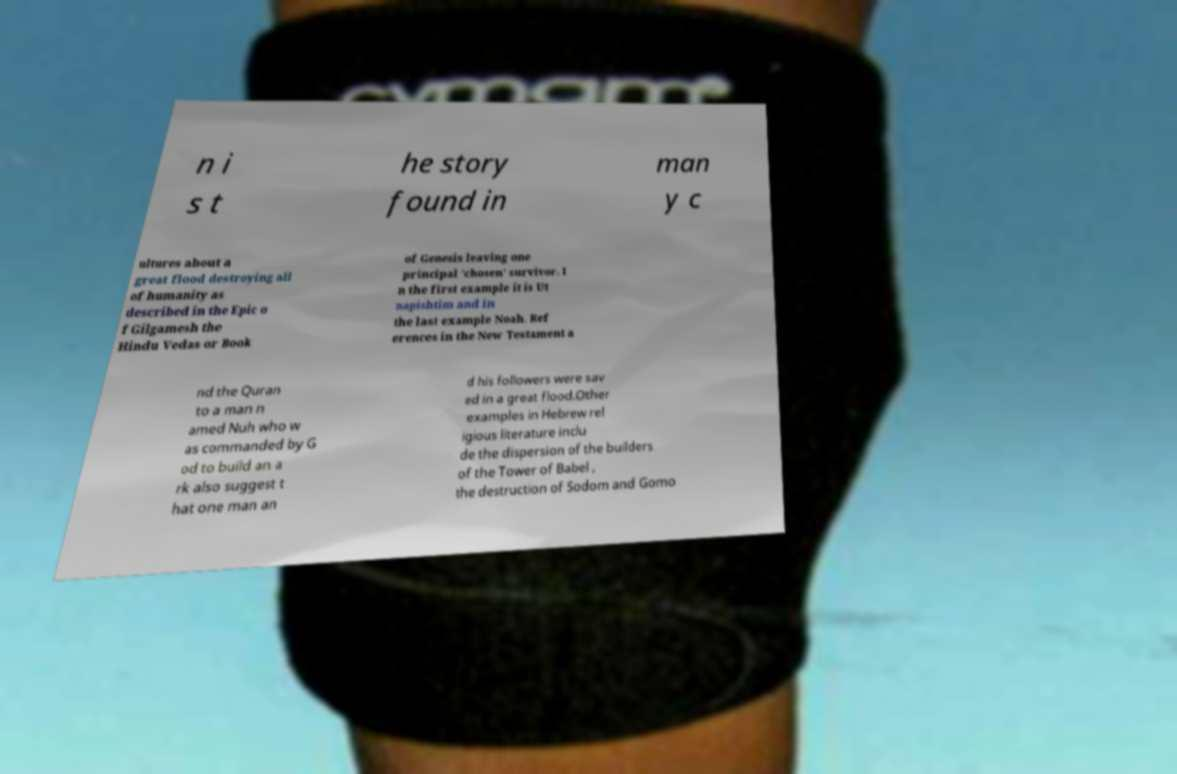Please identify and transcribe the text found in this image. n i s t he story found in man y c ultures about a great flood destroying all of humanity as described in the Epic o f Gilgamesh the Hindu Vedas or Book of Genesis leaving one principal 'chosen' survivor. I n the first example it is Ut napishtim and in the last example Noah. Ref erences in the New Testament a nd the Quran to a man n amed Nuh who w as commanded by G od to build an a rk also suggest t hat one man an d his followers were sav ed in a great flood.Other examples in Hebrew rel igious literature inclu de the dispersion of the builders of the Tower of Babel , the destruction of Sodom and Gomo 